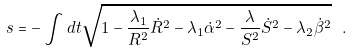Convert formula to latex. <formula><loc_0><loc_0><loc_500><loc_500>s = - \int d t \sqrt { 1 - \frac { \lambda _ { 1 } } { R ^ { 2 } } \dot { R } ^ { 2 } - \lambda _ { 1 } \dot { \alpha } ^ { 2 } - \frac { \lambda } { S ^ { 2 } } \dot { S } ^ { 2 } - \lambda _ { 2 } \dot { \beta } ^ { 2 } } \ .</formula> 